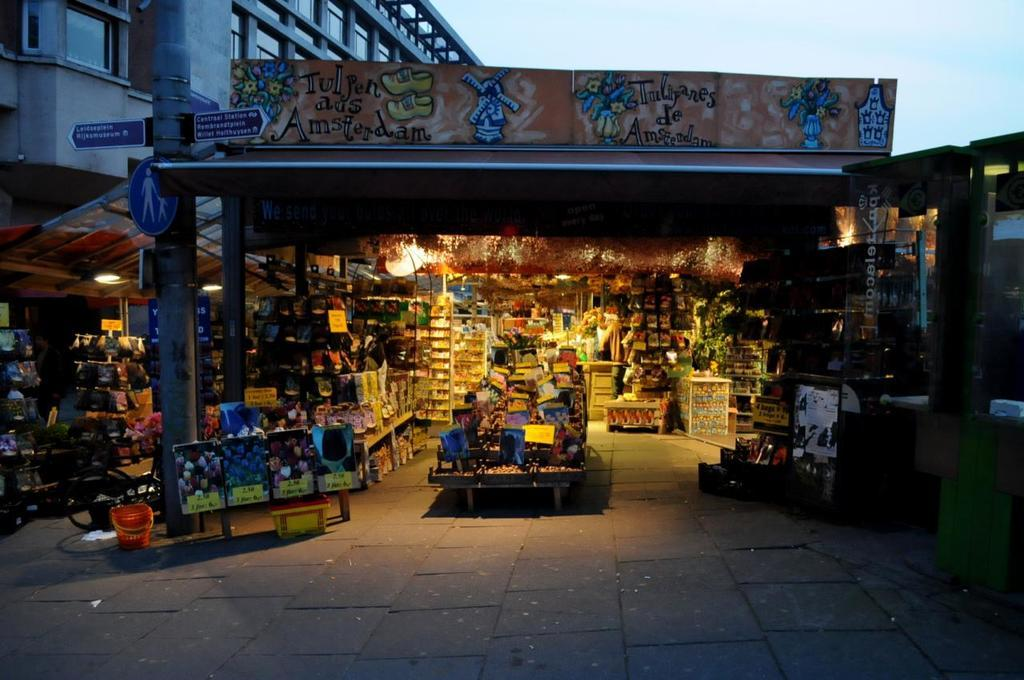What type of establishment is shown in the image? There is a store in the image. What can be found inside the store? The store has a lot of items. What is located on the left side of the image? There is a building on the left side of the image. What type of committee is meeting in the store in the image? There is no committee meeting in the store in the image; it is a store with a lot of items. 